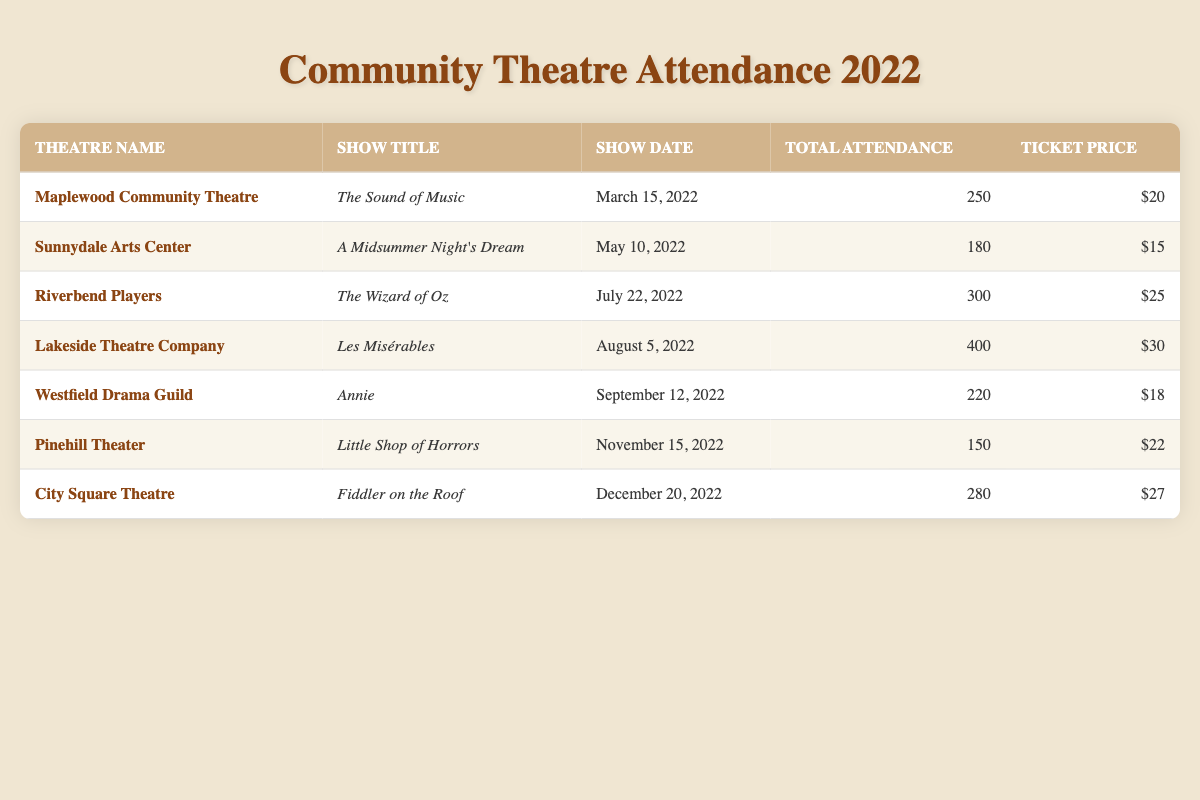What was the total attendance for "Les Misérables"? The table shows the entry for "Les Misérables" under Lakeside Theatre Company, where the total attendance is listed as 400.
Answer: 400 How much was the ticket price for "The Wizard of Oz"? By looking at the entry for "The Wizard of Oz" performed by Riverbend Players, the ticket price is listed as $25.
Answer: $25 Which show had the highest attendance? By comparing the total attendance figures for each show, "Les Misérables" at Lakeside Theatre Company has the highest attendance at 400.
Answer: Les Misérables What is the average ticket price across all shows? Summing the ticket prices ($20 + $15 + $25 + $30 + $18 + $22 + $27) gives a total of $167. Since there are 7 shows, the average price is $167 / 7 = approximately $23.86.
Answer: 23.86 Did "Little Shop of Horrors" have an attendance of more than 200? The attendance for "Little Shop of Horrors" is listed as 150, which is not more than 200.
Answer: No Which show had the lowest attendance? Looking through the attendance numbers, "Little Shop of Horrors" has the lowest attendance recorded at 150.
Answer: Little Shop of Horrors What is the total attendance for shows performed in the second half of the year (July - December)? The shows in the second half are "The Wizard of Oz" (300), "Les Misérables" (400), "Annie" (220), "Little Shop of Horrors" (150), and "Fiddler on the Roof" (280). Summing them gives 300 + 400 + 220 + 150 + 280 = 1350.
Answer: 1350 Is the ticket price for "A Midsummer Night's Dream" higher than that for "Annie"? The ticket price for "A Midsummer Night's Dream" is $15 and for "Annie" it is $18, which means "A Midsummer Night's Dream" has a lower price.
Answer: No What was the total attendance for shows with ticket prices above $25? The shows with ticket prices above $25 are "Les Misérables" ($30, attendance 400) and "Fiddler on the Roof" ($27, attendance 280). Adding these gives 400 + 280 = 680.
Answer: 680 